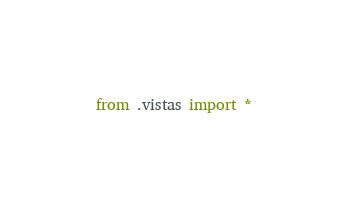<code> <loc_0><loc_0><loc_500><loc_500><_Python_>from .vistas import *</code> 